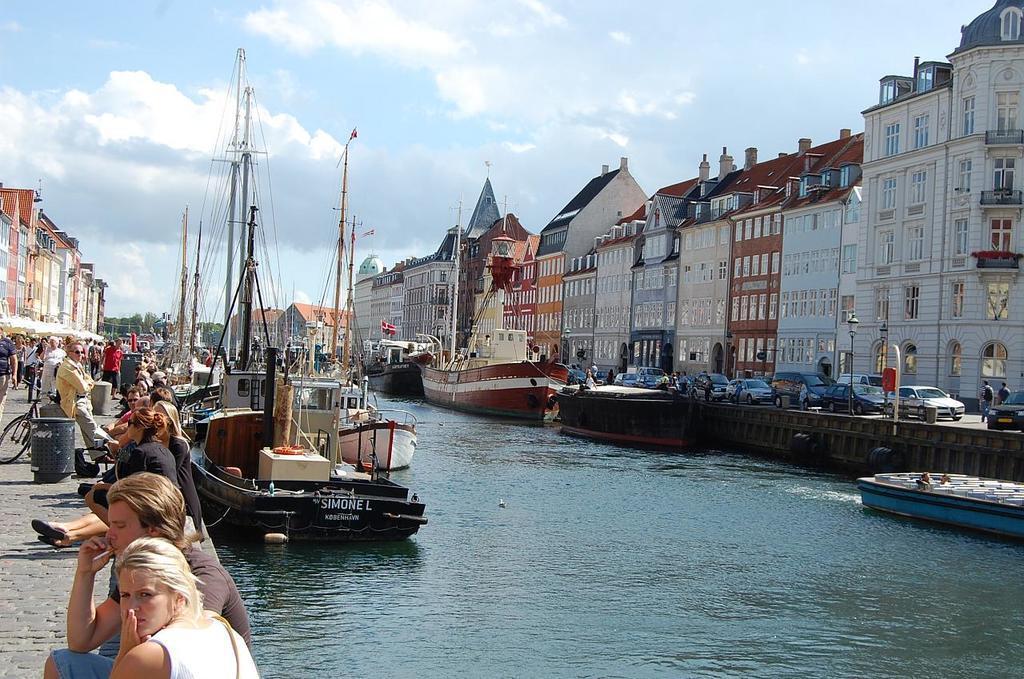In one or two sentences, can you explain what this image depicts? In this picture I can see buildings and few boats in the water and I can see few are sitting and few are standing and I can see a bicycle and few cars and I can see a blue cloudy sky. 